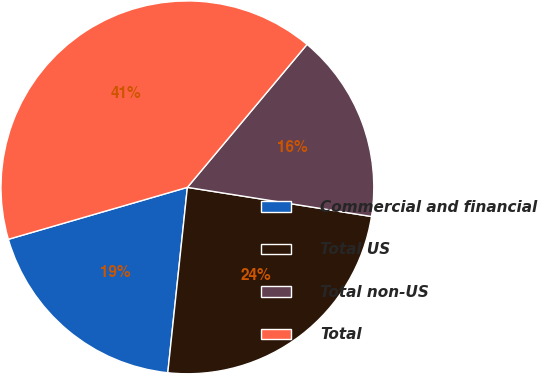Convert chart. <chart><loc_0><loc_0><loc_500><loc_500><pie_chart><fcel>Commercial and financial<fcel>Total US<fcel>Total non-US<fcel>Total<nl><fcel>18.83%<fcel>24.18%<fcel>16.41%<fcel>40.59%<nl></chart> 